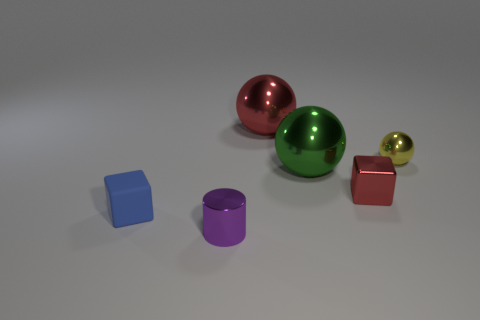Can you tell me the different shapes that you see in the image? Certainly! There are cubes, a sphere, and a cylinder visible in the image. Specifically, there are two cubes, one cylinder, and three spherical objects. 